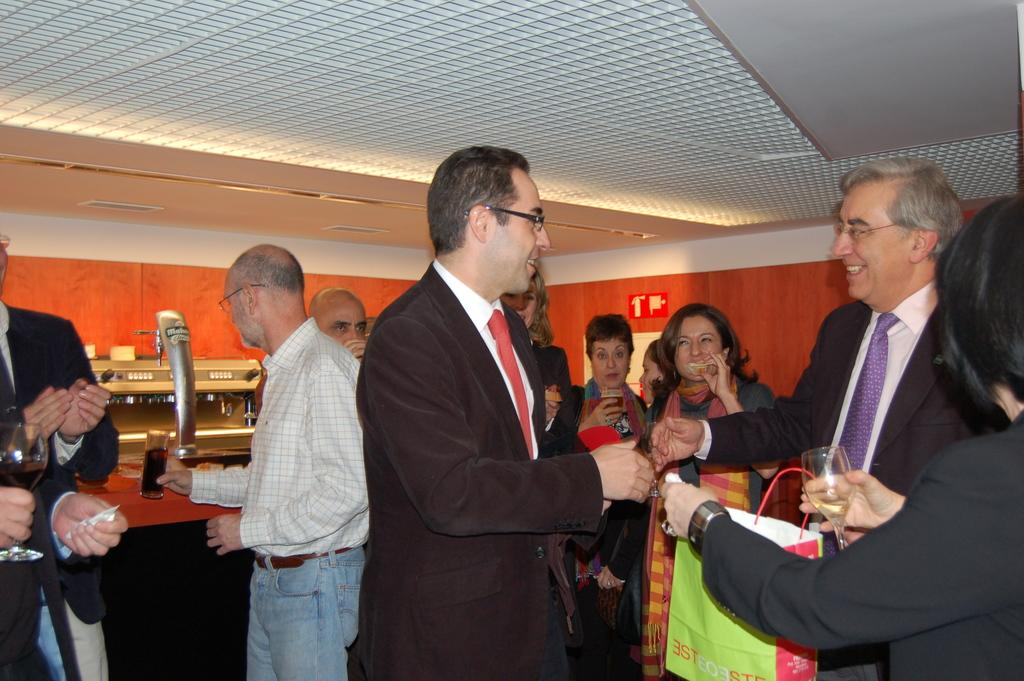What is happening in the image involving a group of people? There is a group of people in the image, and they are holding glasses in their hands. What can be seen in the background of the image? In the background of the image, there is a board, a wall, and lights visible. What part of the room is visible in the image? The ceiling is visible in the image. What type of argument can be seen taking place between the people in the image? There is no argument present in the image; the people are simply holding glasses in their hands. Can you tell me how many drawers are visible in the image? There are no drawers present in the image. 